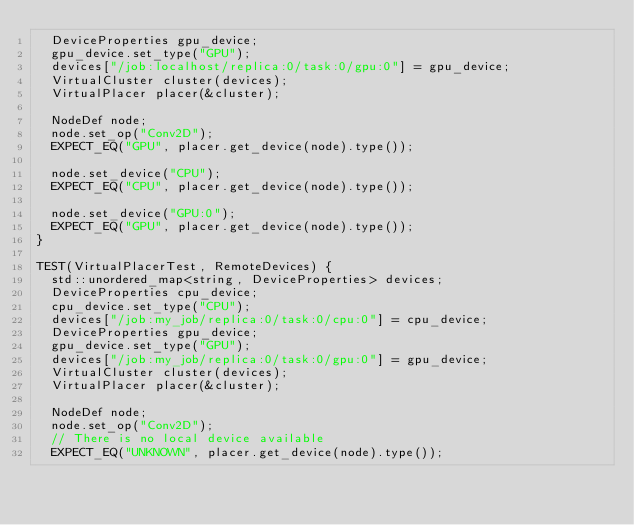<code> <loc_0><loc_0><loc_500><loc_500><_C++_>  DeviceProperties gpu_device;
  gpu_device.set_type("GPU");
  devices["/job:localhost/replica:0/task:0/gpu:0"] = gpu_device;
  VirtualCluster cluster(devices);
  VirtualPlacer placer(&cluster);

  NodeDef node;
  node.set_op("Conv2D");
  EXPECT_EQ("GPU", placer.get_device(node).type());

  node.set_device("CPU");
  EXPECT_EQ("CPU", placer.get_device(node).type());

  node.set_device("GPU:0");
  EXPECT_EQ("GPU", placer.get_device(node).type());
}

TEST(VirtualPlacerTest, RemoteDevices) {
  std::unordered_map<string, DeviceProperties> devices;
  DeviceProperties cpu_device;
  cpu_device.set_type("CPU");
  devices["/job:my_job/replica:0/task:0/cpu:0"] = cpu_device;
  DeviceProperties gpu_device;
  gpu_device.set_type("GPU");
  devices["/job:my_job/replica:0/task:0/gpu:0"] = gpu_device;
  VirtualCluster cluster(devices);
  VirtualPlacer placer(&cluster);

  NodeDef node;
  node.set_op("Conv2D");
  // There is no local device available
  EXPECT_EQ("UNKNOWN", placer.get_device(node).type());
</code> 